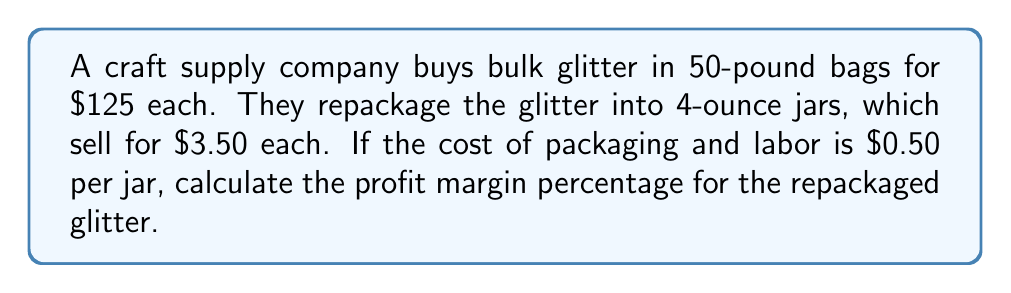Show me your answer to this math problem. To calculate the profit margin percentage, we need to follow these steps:

1. Calculate the number of 4-ounce jars per 50-pound bag:
   $$ \text{Number of jars} = \frac{50 \text{ pounds} \times 16 \text{ oz/lb}}{4 \text{ oz/jar}} = 200 \text{ jars} $$

2. Calculate the revenue from selling all jars from one bag:
   $$ \text{Revenue} = 200 \text{ jars} \times \$3.50/\text{jar} = \$700 $$

3. Calculate the total cost per bag:
   $$ \text{Cost} = \$125 \text{ (bulk bag)} + (200 \text{ jars} \times \$0.50/\text{jar}) = \$225 $$

4. Calculate the profit:
   $$ \text{Profit} = \text{Revenue} - \text{Cost} = \$700 - \$225 = \$475 $$

5. Calculate the profit margin percentage:
   $$ \text{Profit Margin } \% = \frac{\text{Profit}}{\text{Revenue}} \times 100\% $$
   $$ = \frac{\$475}{\$700} \times 100\% = 0.6785714286 \times 100\% \approx 67.86\% $$
Answer: 67.86% 